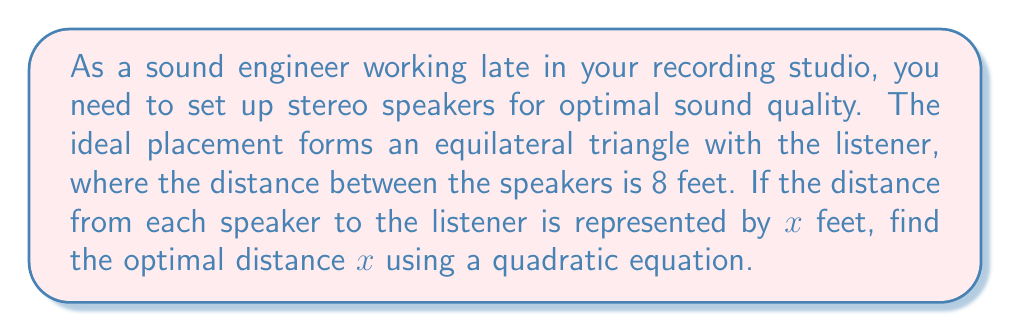Could you help me with this problem? Let's approach this step-by-step:

1) In an equilateral triangle, all sides are equal. We know the distance between speakers is 8 feet, so this forms the base of our triangle.

2) We can split this equilateral triangle into two right triangles. Let's focus on one of these right triangles.

3) In this right triangle:
   - The base (half the distance between speakers) is 4 feet
   - The hypotenuse is $x$ feet (distance from speaker to listener)
   - The height is the distance from the listener to the line between the speakers

4) We can use the Pythagorean theorem to set up our equation:

   $$ 4^2 + h^2 = x^2 $$

   Where $h$ is the height of the triangle.

5) In an equilateral triangle, the height $h$ can be expressed in terms of the side length $x$:

   $$ h = \frac{\sqrt{3}}{2}x $$

6) Substituting this into our Pythagorean equation:

   $$ 4^2 + (\frac{\sqrt{3}}{2}x)^2 = x^2 $$

7) Simplify:

   $$ 16 + \frac{3}{4}x^2 = x^2 $$

8) Rearrange to standard quadratic form:

   $$ \frac{3}{4}x^2 - x^2 + 16 = 0 $$
   $$ -\frac{1}{4}x^2 + 16 = 0 $$

9) Multiply all terms by -4 to eliminate fractions:

   $$ x^2 - 64 = 0 $$

10) Solve for $x$:

    $$ x^2 = 64 $$
    $$ x = \pm 8 $$

11) Since distance can't be negative, our solution is $x = 8$ feet.
Answer: 8 feet 